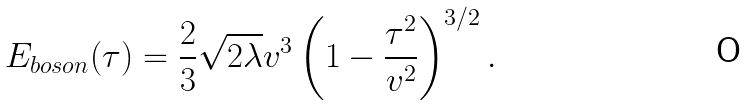Convert formula to latex. <formula><loc_0><loc_0><loc_500><loc_500>E _ { b o s o n } ( \tau ) = { \frac { 2 } { 3 } } \sqrt { 2 \lambda } v ^ { 3 } \left ( 1 - { \frac { \tau ^ { 2 } } { v ^ { 2 } } } \right ) ^ { 3 / 2 } .</formula> 